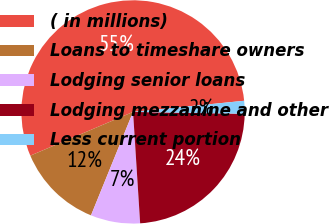Convert chart. <chart><loc_0><loc_0><loc_500><loc_500><pie_chart><fcel>( in millions)<fcel>Loans to timeshare owners<fcel>Lodging senior loans<fcel>Lodging mezzanine and other<fcel>Less current portion<nl><fcel>54.82%<fcel>12.45%<fcel>7.16%<fcel>23.72%<fcel>1.86%<nl></chart> 